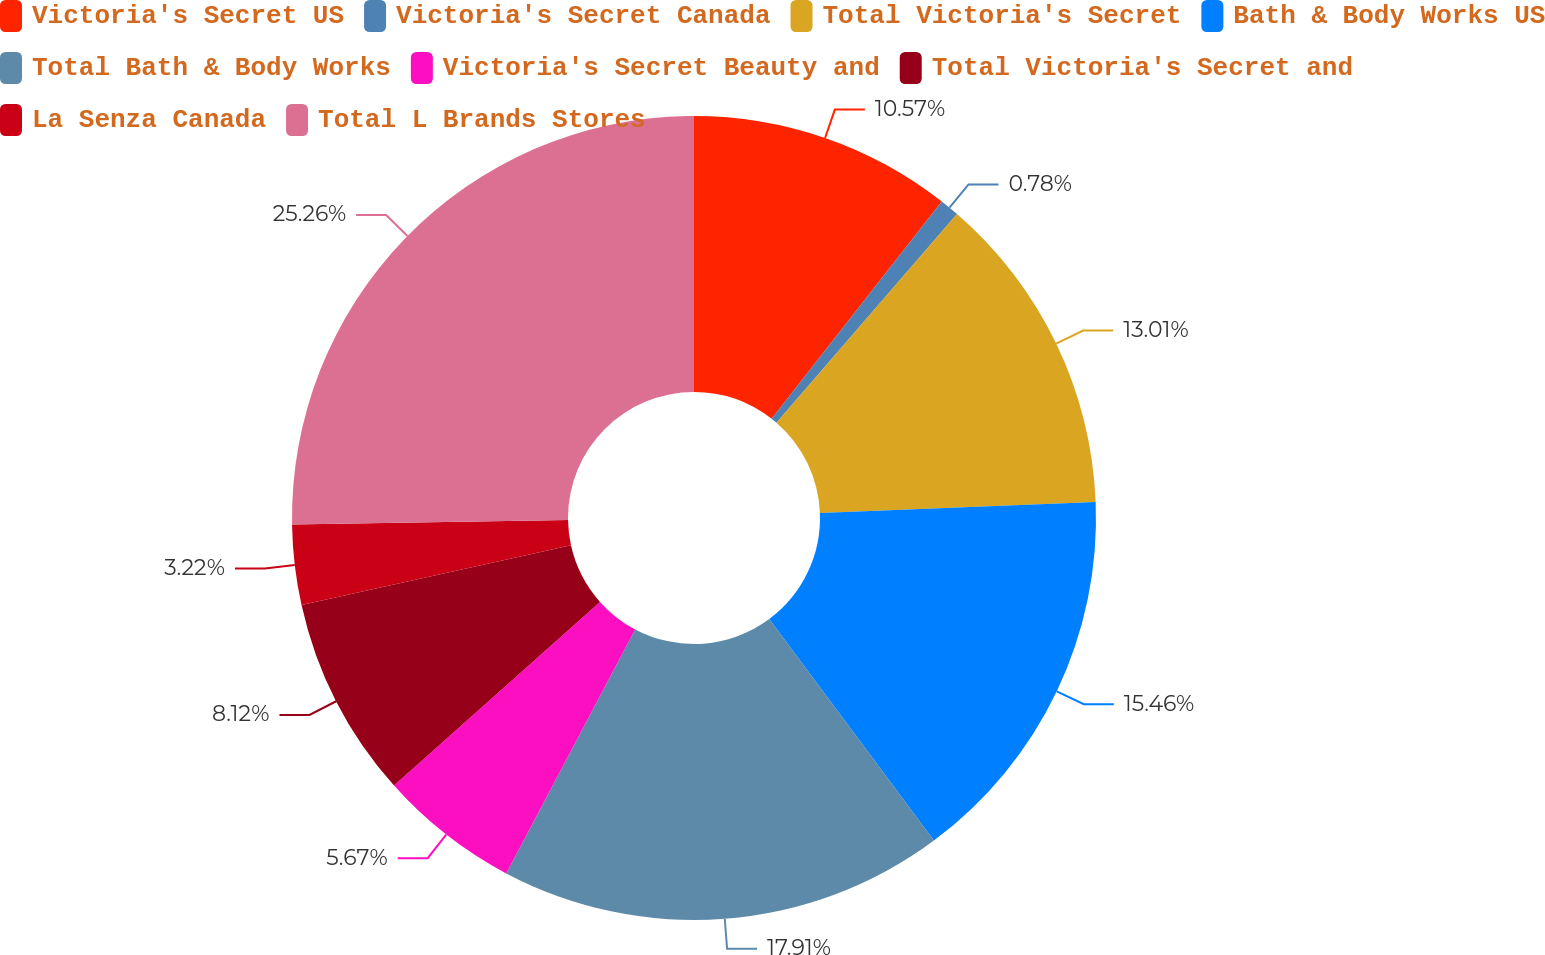<chart> <loc_0><loc_0><loc_500><loc_500><pie_chart><fcel>Victoria's Secret US<fcel>Victoria's Secret Canada<fcel>Total Victoria's Secret<fcel>Bath & Body Works US<fcel>Total Bath & Body Works<fcel>Victoria's Secret Beauty and<fcel>Total Victoria's Secret and<fcel>La Senza Canada<fcel>Total L Brands Stores<nl><fcel>10.57%<fcel>0.78%<fcel>13.01%<fcel>15.46%<fcel>17.91%<fcel>5.67%<fcel>8.12%<fcel>3.22%<fcel>25.25%<nl></chart> 